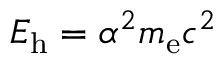Convert formula to latex. <formula><loc_0><loc_0><loc_500><loc_500>E _ { h } = \alpha ^ { 2 } m _ { e } c ^ { 2 }</formula> 